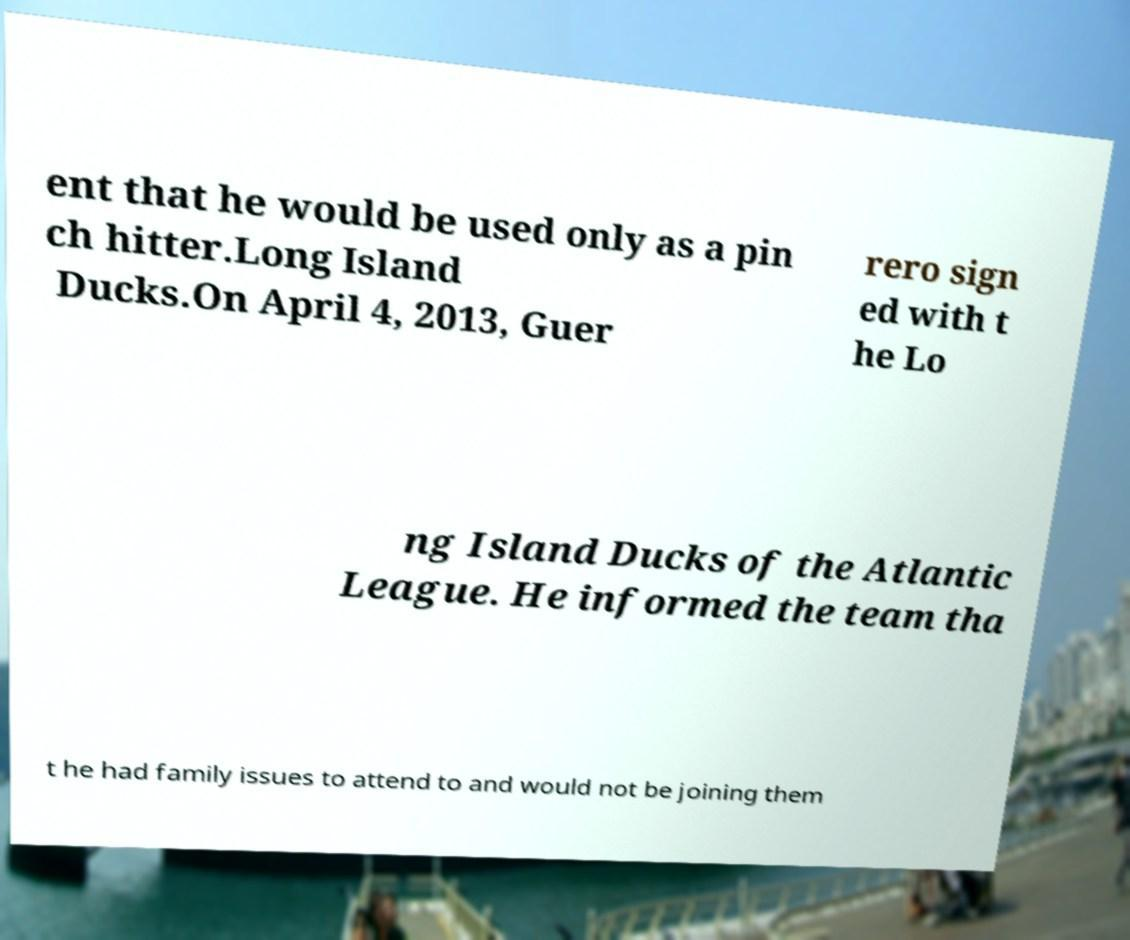There's text embedded in this image that I need extracted. Can you transcribe it verbatim? ent that he would be used only as a pin ch hitter.Long Island Ducks.On April 4, 2013, Guer rero sign ed with t he Lo ng Island Ducks of the Atlantic League. He informed the team tha t he had family issues to attend to and would not be joining them 